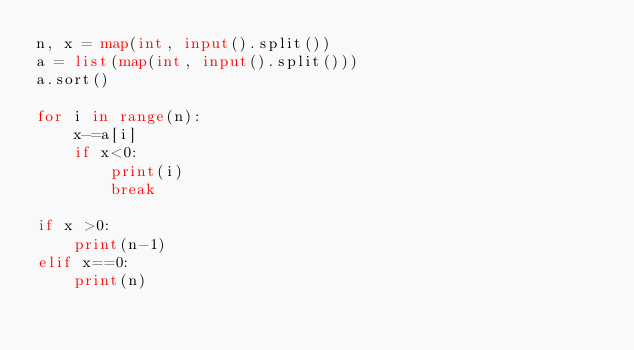Convert code to text. <code><loc_0><loc_0><loc_500><loc_500><_Python_>n, x = map(int, input().split())
a = list(map(int, input().split()))
a.sort()

for i in range(n):
    x-=a[i]
    if x<0:
        print(i)
        break

if x >0:
    print(n-1)
elif x==0:
    print(n)
</code> 